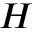<formula> <loc_0><loc_0><loc_500><loc_500>H</formula> 